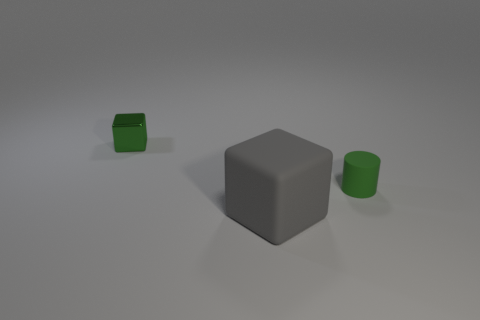Are there more tiny matte things behind the gray matte cube than small metal objects that are in front of the green cylinder? Upon reviewing the image, it appears that there are no small metal objects in front of the green cylinder whatsoever. Therefore, even though we have just one tiny matte green cube behind the gray matte cube, the answer is yes — there are indeed more tiny matte things behind the gray matte cube than small metal objects in front of the green cylinder, as the latter count is zero. 